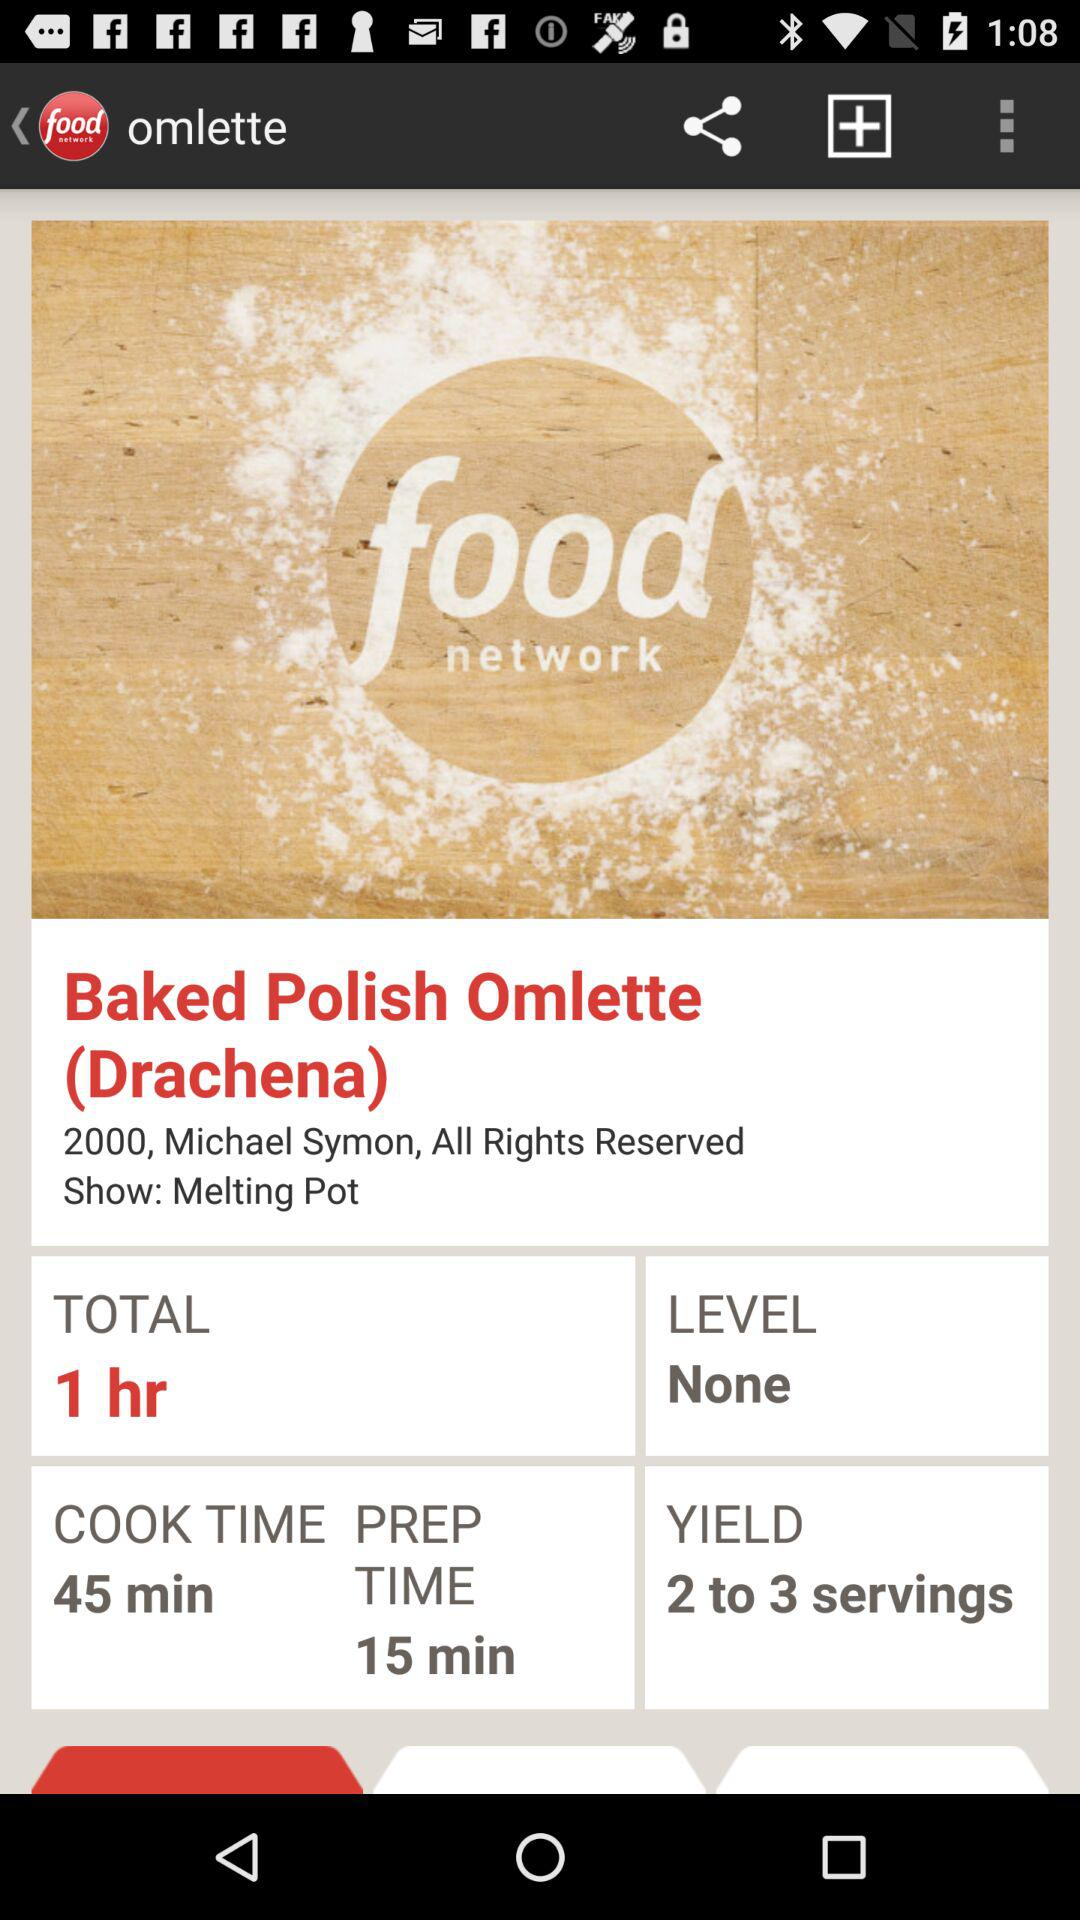How much longer is the cook time than the prep time?
Answer the question using a single word or phrase. 30 minutes 